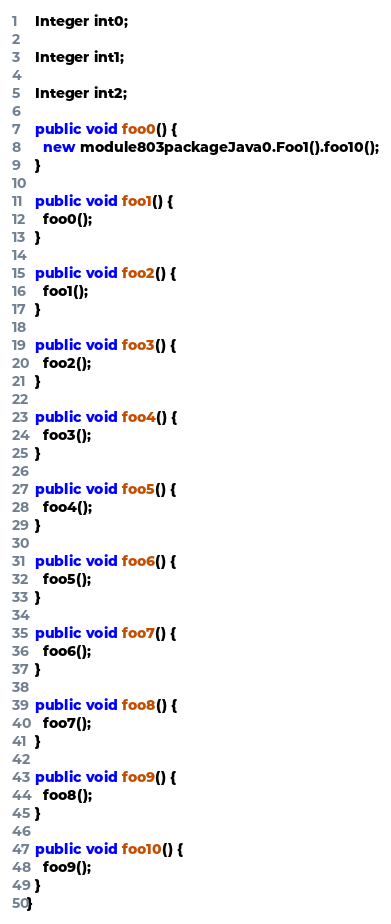<code> <loc_0><loc_0><loc_500><loc_500><_Java_>  Integer int0;

  Integer int1;

  Integer int2;

  public void foo0() {
    new module803packageJava0.Foo1().foo10();
  }

  public void foo1() {
    foo0();
  }

  public void foo2() {
    foo1();
  }

  public void foo3() {
    foo2();
  }

  public void foo4() {
    foo3();
  }

  public void foo5() {
    foo4();
  }

  public void foo6() {
    foo5();
  }

  public void foo7() {
    foo6();
  }

  public void foo8() {
    foo7();
  }

  public void foo9() {
    foo8();
  }

  public void foo10() {
    foo9();
  }
}
</code> 